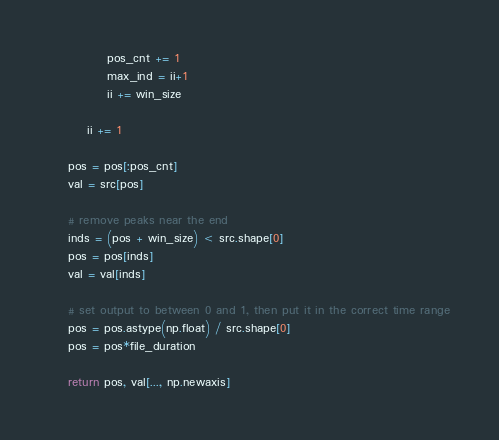Convert code to text. <code><loc_0><loc_0><loc_500><loc_500><_Cython_>            pos_cnt += 1
            max_ind = ii+1
            ii += win_size

        ii += 1

    pos = pos[:pos_cnt]
    val = src[pos]

    # remove peaks near the end
    inds = (pos + win_size) < src.shape[0]
    pos = pos[inds]
    val = val[inds]

    # set output to between 0 and 1, then put it in the correct time range
    pos = pos.astype(np.float) / src.shape[0]
    pos = pos*file_duration

    return pos, val[..., np.newaxis]
</code> 